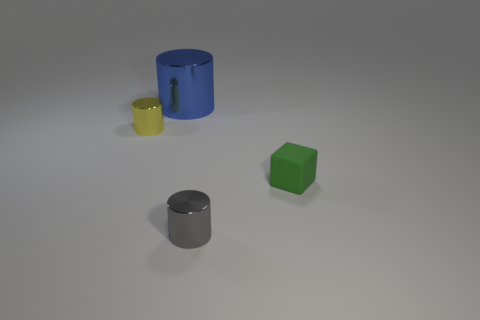Add 4 tiny blue things. How many objects exist? 8 Subtract all cylinders. How many objects are left? 1 Add 3 large purple metallic cubes. How many large purple metallic cubes exist? 3 Subtract 0 green cylinders. How many objects are left? 4 Subtract all tiny yellow things. Subtract all tiny green cubes. How many objects are left? 2 Add 1 shiny cylinders. How many shiny cylinders are left? 4 